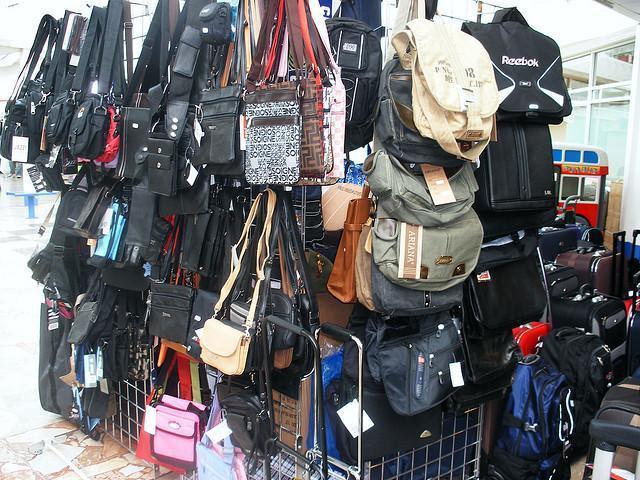How many backpacks are there?
Give a very brief answer. 11. How many handbags are in the picture?
Give a very brief answer. 12. How many suitcases are there?
Give a very brief answer. 3. How many cows are to the left of the person in the middle?
Give a very brief answer. 0. 